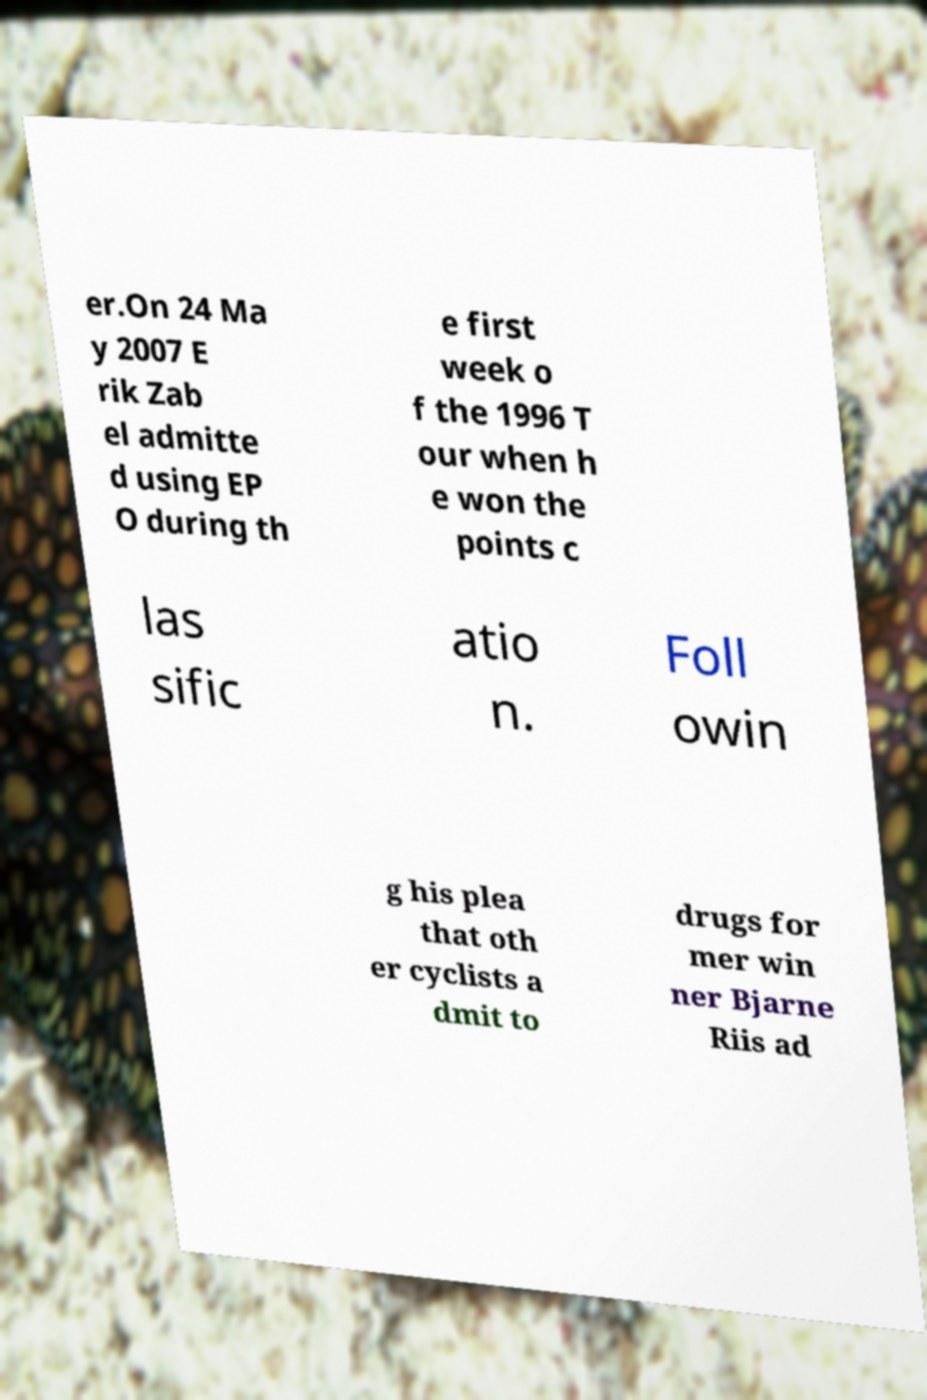Can you read and provide the text displayed in the image?This photo seems to have some interesting text. Can you extract and type it out for me? er.On 24 Ma y 2007 E rik Zab el admitte d using EP O during th e first week o f the 1996 T our when h e won the points c las sific atio n. Foll owin g his plea that oth er cyclists a dmit to drugs for mer win ner Bjarne Riis ad 